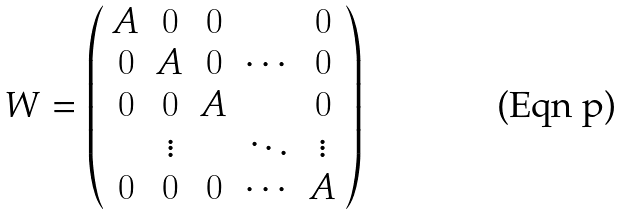Convert formula to latex. <formula><loc_0><loc_0><loc_500><loc_500>W = \left ( \begin{array} { c c c c c } A & 0 & 0 & & 0 \\ 0 & A & 0 & \cdots & 0 \\ 0 & 0 & A & & 0 \\ & \vdots & & \ddots & \vdots \\ 0 & 0 & 0 & \cdots & A \end{array} \right )</formula> 